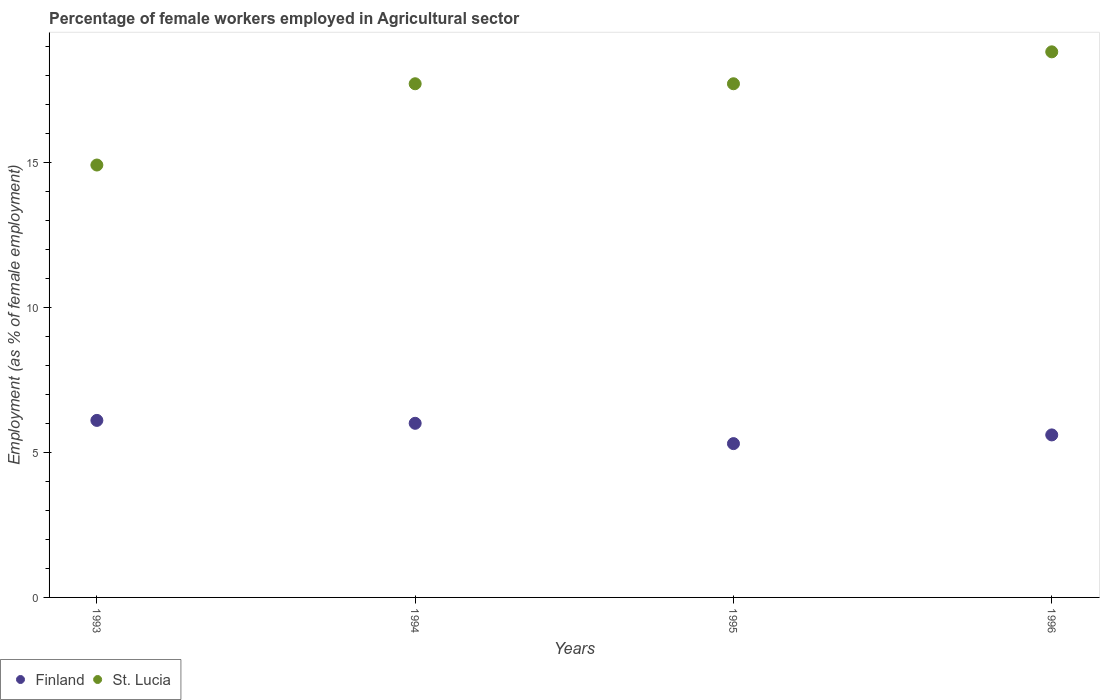What is the percentage of females employed in Agricultural sector in St. Lucia in 1996?
Your answer should be very brief. 18.8. Across all years, what is the maximum percentage of females employed in Agricultural sector in St. Lucia?
Your response must be concise. 18.8. Across all years, what is the minimum percentage of females employed in Agricultural sector in St. Lucia?
Your answer should be compact. 14.9. In which year was the percentage of females employed in Agricultural sector in St. Lucia maximum?
Your answer should be very brief. 1996. What is the total percentage of females employed in Agricultural sector in Finland in the graph?
Provide a short and direct response. 23. What is the difference between the percentage of females employed in Agricultural sector in St. Lucia in 1993 and that in 1995?
Keep it short and to the point. -2.8. What is the difference between the percentage of females employed in Agricultural sector in St. Lucia in 1993 and the percentage of females employed in Agricultural sector in Finland in 1995?
Your response must be concise. 9.6. What is the average percentage of females employed in Agricultural sector in Finland per year?
Your answer should be compact. 5.75. In the year 1994, what is the difference between the percentage of females employed in Agricultural sector in St. Lucia and percentage of females employed in Agricultural sector in Finland?
Your answer should be compact. 11.7. What is the ratio of the percentage of females employed in Agricultural sector in Finland in 1993 to that in 1994?
Your answer should be compact. 1.02. Is the percentage of females employed in Agricultural sector in Finland in 1994 less than that in 1996?
Give a very brief answer. No. Is the difference between the percentage of females employed in Agricultural sector in St. Lucia in 1995 and 1996 greater than the difference between the percentage of females employed in Agricultural sector in Finland in 1995 and 1996?
Offer a terse response. No. What is the difference between the highest and the second highest percentage of females employed in Agricultural sector in Finland?
Your answer should be compact. 0.1. What is the difference between the highest and the lowest percentage of females employed in Agricultural sector in Finland?
Keep it short and to the point. 0.8. In how many years, is the percentage of females employed in Agricultural sector in St. Lucia greater than the average percentage of females employed in Agricultural sector in St. Lucia taken over all years?
Provide a short and direct response. 3. Is the sum of the percentage of females employed in Agricultural sector in St. Lucia in 1995 and 1996 greater than the maximum percentage of females employed in Agricultural sector in Finland across all years?
Your answer should be very brief. Yes. How many years are there in the graph?
Keep it short and to the point. 4. Are the values on the major ticks of Y-axis written in scientific E-notation?
Offer a terse response. No. Does the graph contain grids?
Provide a short and direct response. No. Where does the legend appear in the graph?
Keep it short and to the point. Bottom left. How many legend labels are there?
Your response must be concise. 2. How are the legend labels stacked?
Give a very brief answer. Horizontal. What is the title of the graph?
Your answer should be very brief. Percentage of female workers employed in Agricultural sector. What is the label or title of the X-axis?
Offer a very short reply. Years. What is the label or title of the Y-axis?
Make the answer very short. Employment (as % of female employment). What is the Employment (as % of female employment) in Finland in 1993?
Your response must be concise. 6.1. What is the Employment (as % of female employment) of St. Lucia in 1993?
Provide a short and direct response. 14.9. What is the Employment (as % of female employment) in St. Lucia in 1994?
Ensure brevity in your answer.  17.7. What is the Employment (as % of female employment) in Finland in 1995?
Your answer should be very brief. 5.3. What is the Employment (as % of female employment) of St. Lucia in 1995?
Your response must be concise. 17.7. What is the Employment (as % of female employment) in Finland in 1996?
Give a very brief answer. 5.6. What is the Employment (as % of female employment) in St. Lucia in 1996?
Your response must be concise. 18.8. Across all years, what is the maximum Employment (as % of female employment) in Finland?
Your answer should be compact. 6.1. Across all years, what is the maximum Employment (as % of female employment) of St. Lucia?
Ensure brevity in your answer.  18.8. Across all years, what is the minimum Employment (as % of female employment) of Finland?
Your response must be concise. 5.3. Across all years, what is the minimum Employment (as % of female employment) in St. Lucia?
Your answer should be very brief. 14.9. What is the total Employment (as % of female employment) in St. Lucia in the graph?
Keep it short and to the point. 69.1. What is the difference between the Employment (as % of female employment) in Finland in 1993 and that in 1994?
Make the answer very short. 0.1. What is the difference between the Employment (as % of female employment) of St. Lucia in 1993 and that in 1995?
Offer a terse response. -2.8. What is the difference between the Employment (as % of female employment) of Finland in 1993 and that in 1996?
Ensure brevity in your answer.  0.5. What is the difference between the Employment (as % of female employment) of Finland in 1994 and that in 1995?
Keep it short and to the point. 0.7. What is the difference between the Employment (as % of female employment) in St. Lucia in 1994 and that in 1995?
Give a very brief answer. 0. What is the difference between the Employment (as % of female employment) of St. Lucia in 1994 and that in 1996?
Offer a very short reply. -1.1. What is the difference between the Employment (as % of female employment) of St. Lucia in 1995 and that in 1996?
Your answer should be compact. -1.1. What is the difference between the Employment (as % of female employment) of Finland in 1993 and the Employment (as % of female employment) of St. Lucia in 1994?
Offer a terse response. -11.6. What is the difference between the Employment (as % of female employment) of Finland in 1993 and the Employment (as % of female employment) of St. Lucia in 1995?
Keep it short and to the point. -11.6. What is the difference between the Employment (as % of female employment) in Finland in 1994 and the Employment (as % of female employment) in St. Lucia in 1995?
Your response must be concise. -11.7. What is the difference between the Employment (as % of female employment) of Finland in 1995 and the Employment (as % of female employment) of St. Lucia in 1996?
Your answer should be compact. -13.5. What is the average Employment (as % of female employment) in Finland per year?
Ensure brevity in your answer.  5.75. What is the average Employment (as % of female employment) of St. Lucia per year?
Your response must be concise. 17.27. In the year 1993, what is the difference between the Employment (as % of female employment) in Finland and Employment (as % of female employment) in St. Lucia?
Your response must be concise. -8.8. In the year 1994, what is the difference between the Employment (as % of female employment) of Finland and Employment (as % of female employment) of St. Lucia?
Offer a terse response. -11.7. In the year 1995, what is the difference between the Employment (as % of female employment) in Finland and Employment (as % of female employment) in St. Lucia?
Offer a terse response. -12.4. In the year 1996, what is the difference between the Employment (as % of female employment) in Finland and Employment (as % of female employment) in St. Lucia?
Your response must be concise. -13.2. What is the ratio of the Employment (as % of female employment) in Finland in 1993 to that in 1994?
Offer a very short reply. 1.02. What is the ratio of the Employment (as % of female employment) in St. Lucia in 1993 to that in 1994?
Provide a short and direct response. 0.84. What is the ratio of the Employment (as % of female employment) in Finland in 1993 to that in 1995?
Your answer should be very brief. 1.15. What is the ratio of the Employment (as % of female employment) of St. Lucia in 1993 to that in 1995?
Your answer should be very brief. 0.84. What is the ratio of the Employment (as % of female employment) in Finland in 1993 to that in 1996?
Offer a very short reply. 1.09. What is the ratio of the Employment (as % of female employment) in St. Lucia in 1993 to that in 1996?
Ensure brevity in your answer.  0.79. What is the ratio of the Employment (as % of female employment) in Finland in 1994 to that in 1995?
Give a very brief answer. 1.13. What is the ratio of the Employment (as % of female employment) in St. Lucia in 1994 to that in 1995?
Provide a succinct answer. 1. What is the ratio of the Employment (as % of female employment) of Finland in 1994 to that in 1996?
Your answer should be very brief. 1.07. What is the ratio of the Employment (as % of female employment) of St. Lucia in 1994 to that in 1996?
Provide a short and direct response. 0.94. What is the ratio of the Employment (as % of female employment) of Finland in 1995 to that in 1996?
Make the answer very short. 0.95. What is the ratio of the Employment (as % of female employment) in St. Lucia in 1995 to that in 1996?
Offer a very short reply. 0.94. What is the difference between the highest and the second highest Employment (as % of female employment) in Finland?
Offer a terse response. 0.1. What is the difference between the highest and the second highest Employment (as % of female employment) of St. Lucia?
Keep it short and to the point. 1.1. What is the difference between the highest and the lowest Employment (as % of female employment) of Finland?
Keep it short and to the point. 0.8. 